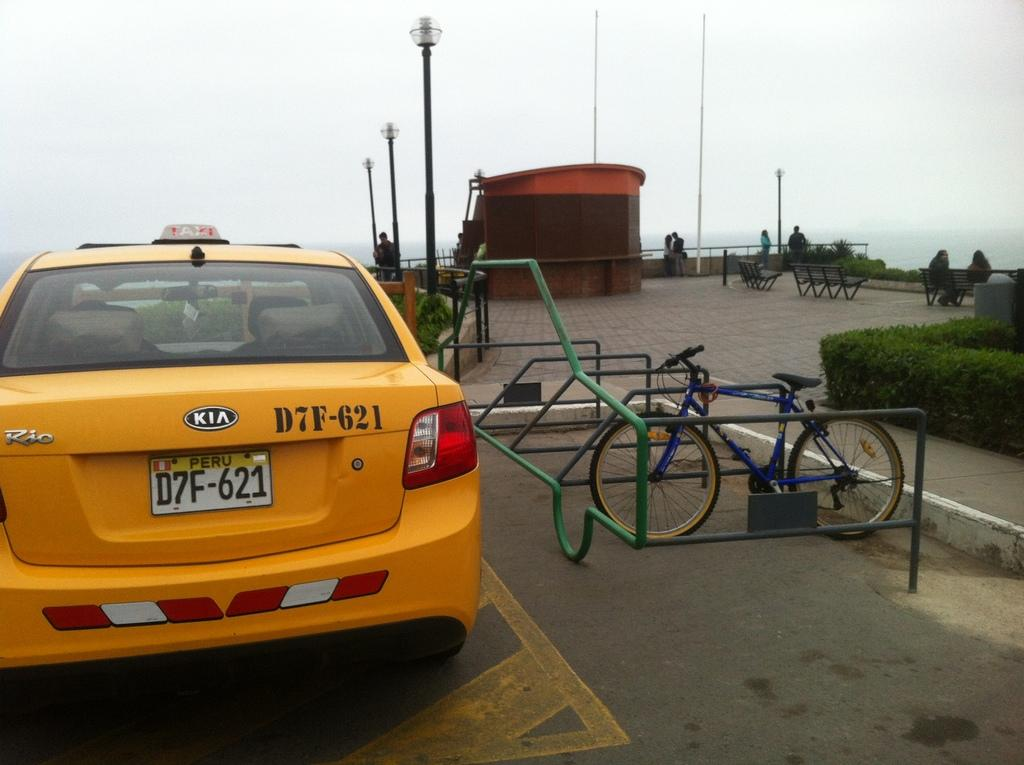<image>
Give a short and clear explanation of the subsequent image. A yellow taxi with the license plate of D7F-621 is parked near a bike. 